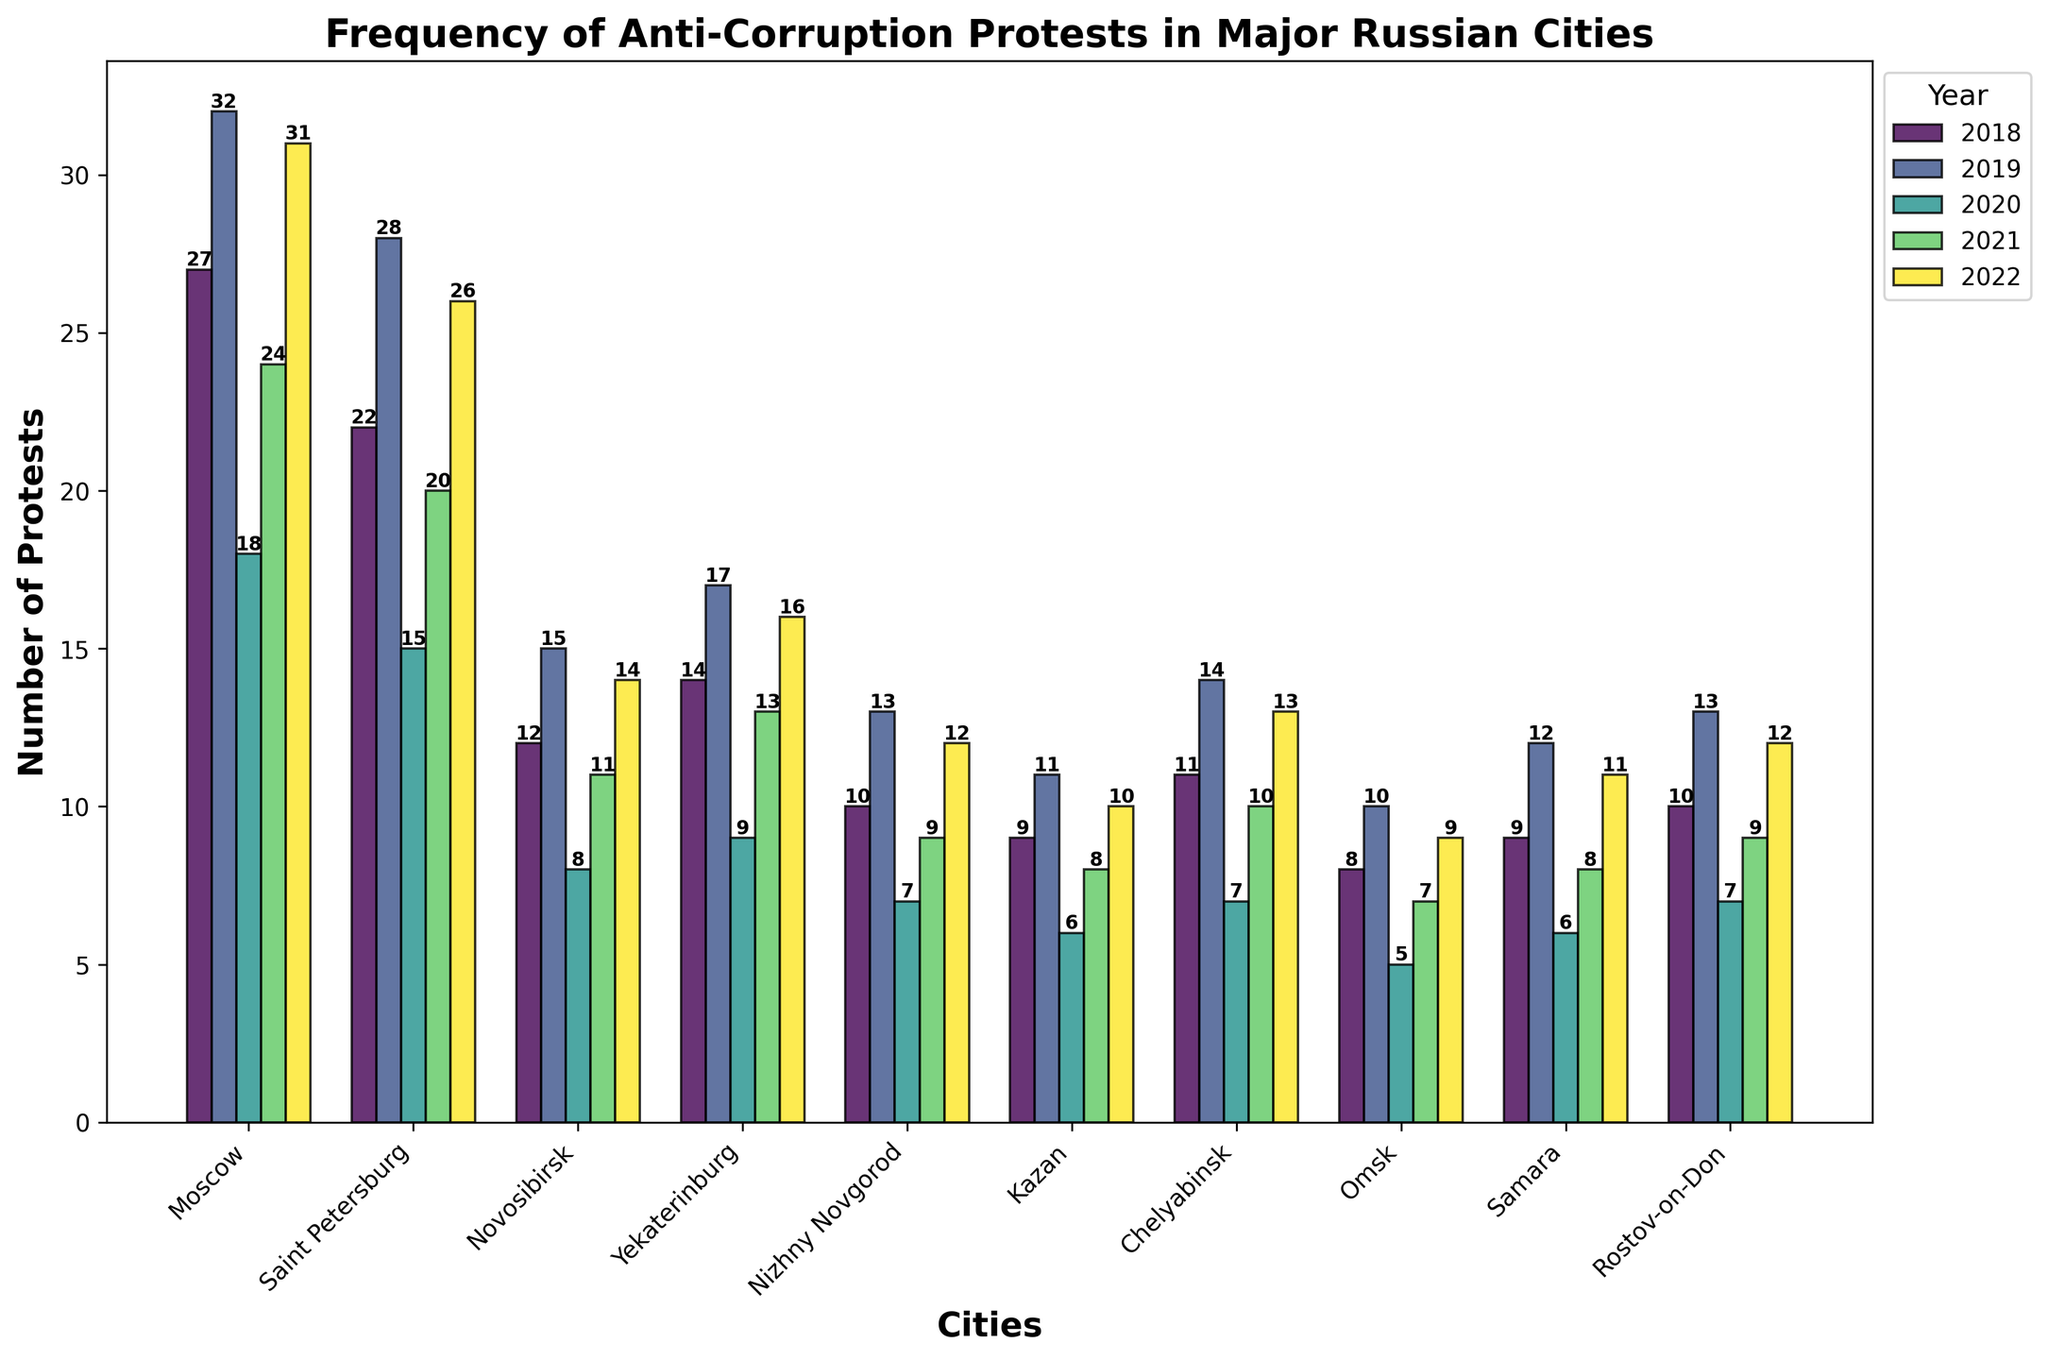Which city had the highest number of protests in 2019? Look at the bars representing the year 2019 and identify the city with the tallest bar. Moscow has the highest number of protests with 32.
Answer: Moscow Which year had the lowest number of protests in Saint Petersburg? Look at the bars corresponding to Saint Petersburg and identify the shortest bar. The year 2020 has the lowest number of protests with 15.
Answer: 2020 What is the total number of protests held in Yekaterinburg from 2018 to 2022? Add up the number of protests in Yekaterinburg for each year: 14 (2018) + 17 (2019) + 9 (2020) + 13 (2021) + 16 (2022). The total is 69.
Answer: 69 How did the number of protests in Moscow change from 2018 to 2022? Compare the heights of the bars for Moscow from 2018 to 2022: 27 (2018) to 32 (2019) to 18 (2020) to 24 (2021) to 31 (2022). The pattern shows a rise, drop, and rise again.
Answer: Rise, drop, and rise again Which city showed the most improvement in protest frequency from 2020 to 2021? Compare the difference in bar heights for each city between 2020 and 2021. Moscow has the most improvement, increasing from 18 to 24, a difference of 6.
Answer: Moscow What is the average number of protests in Kazan from 2018 to 2022? Add up the number of protests in Kazan for each year and divide by 5: (9 + 11 + 6 + 8 + 10) / 5 = 44 / 5 = 8.8.
Answer: 8.8 Which city had the least fluctuation in the number of protests over the five years? Compare the range (difference between the highest and lowest bar) for each city. Kazan has the least fluctuation with a range of (11 - 6 = 5).
Answer: Kazan How many more protests were there in Moscow compared to Novosibirsk in 2022? Subtract the number of protests in Novosibirsk from the number in Moscow for 2022: 31 (Moscow) - 14 (Novosibirsk) = 17.
Answer: 17 Which two cities had an equal number of protests in any given year? Look for years where the bars for two cities are of equal height. Nizhny Novgorod and Rostov-on-Don both had 10 protests in 2018 and 12 protests in 2022.
Answer: Nizhny Novgorod and Rostov-on-Don Which city had a consistent increase in protests every year from 2019 to 2022? Check the progression of each city's bars from 2019 to 2022. None of the cities had a consistent increase every year; they all have ups and downs.
Answer: None 